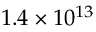<formula> <loc_0><loc_0><loc_500><loc_500>1 . 4 \times 1 0 ^ { 1 3 }</formula> 